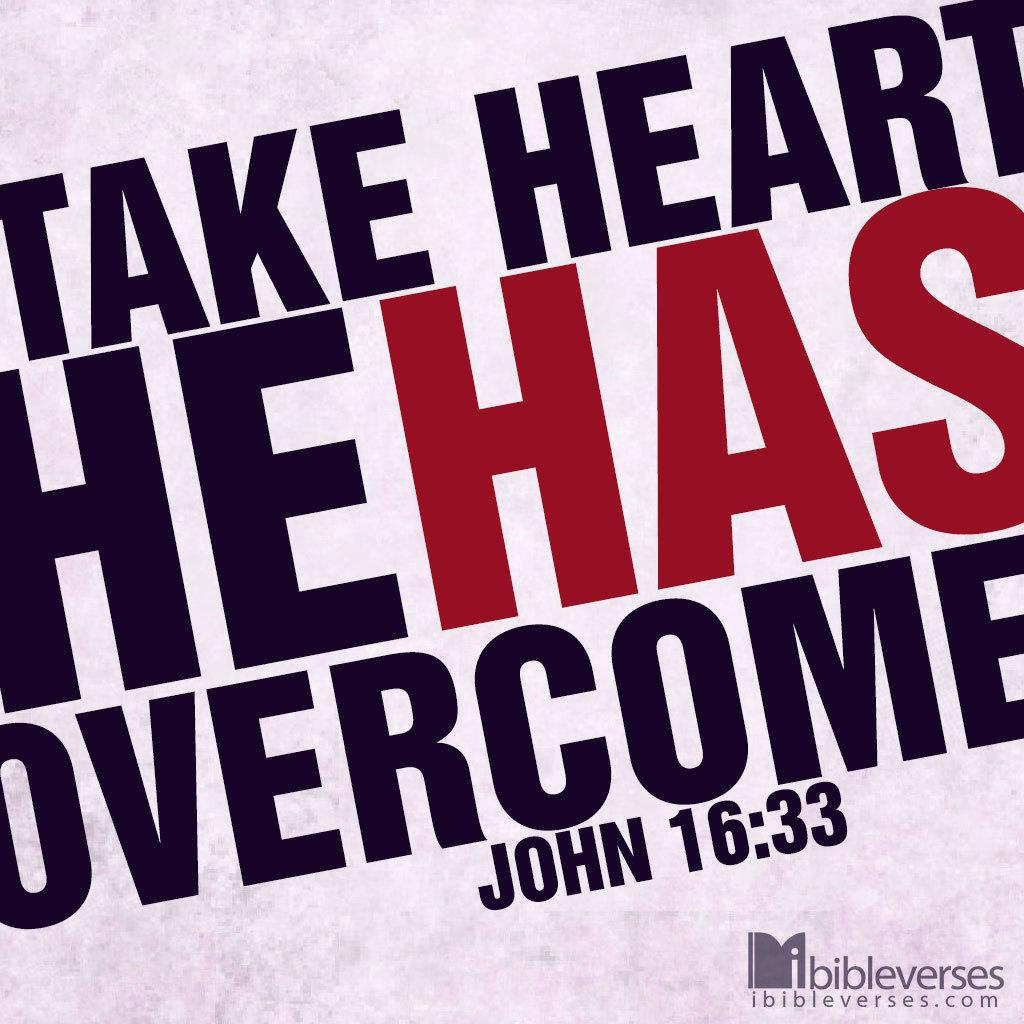Provide a one-sentence caption for the provided image. The bible verse, John 16:33, is rendered in a large contrasting color design. 